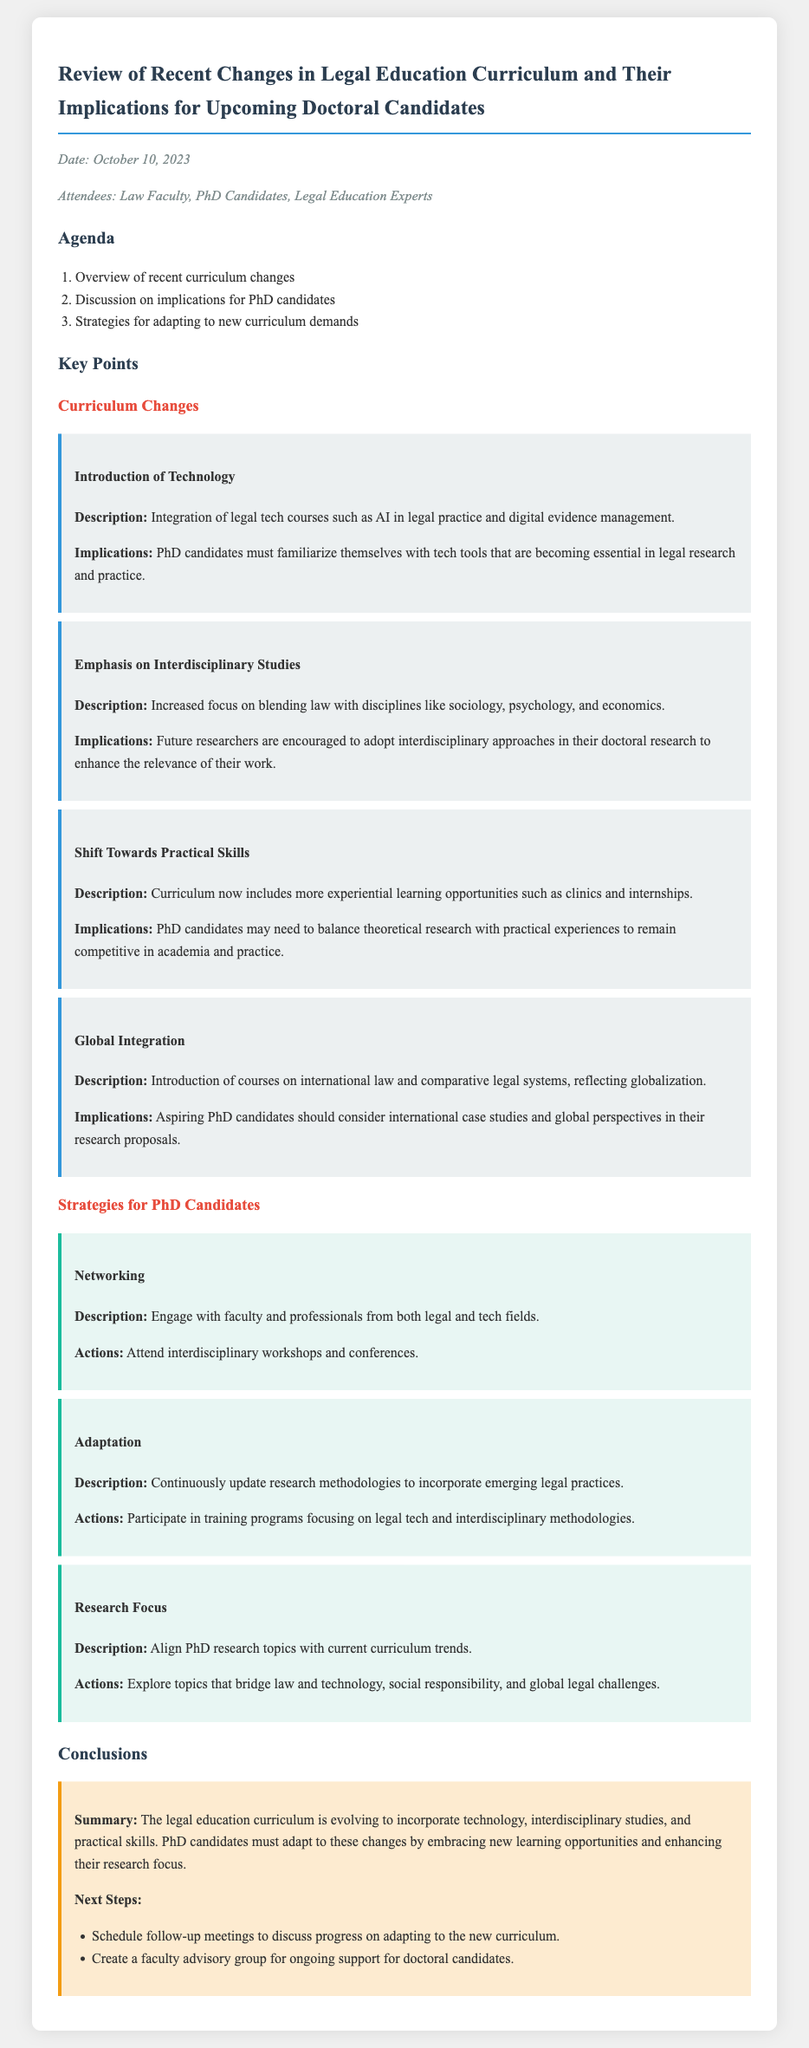What is the date of the meeting? The date of the meeting is explicitly mentioned in the document.
Answer: October 10, 2023 Who attended the meeting? The document lists the attendees of the meeting for clarity.
Answer: Law Faculty, PhD Candidates, Legal Education Experts What is one technology course introduced in the curriculum? The document provides specific examples of new courses added to the curriculum.
Answer: AI in legal practice What is emphasized in the curriculum changes besides technology? The key points detail multiple focal areas of the new curriculum.
Answer: Interdisciplinary Studies What type of learning opportunities are included in the new curriculum? The document specifies changes related to practical application in the curriculum.
Answer: Experiential learning opportunities What should PhD candidates focus on in their research topics? Strategies for adapting to the curriculum highlight areas of focus for PhD research.
Answer: Current curriculum trends What is the main implication of the shift towards practical skills? The document discusses how this shift affects PhD candidates' competitiveness.
Answer: Balance theoretical research with practical experiences What should PhD candidates engage in to enhance their networking? The document provides specific recommendations for networking actions.
Answer: Interdisciplinary workshops and conferences How will the faculty support doctoral candidates? The document outlines proposed next steps for ongoing support for PhD candidates.
Answer: Faculty advisory group 